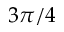<formula> <loc_0><loc_0><loc_500><loc_500>3 \pi / 4</formula> 